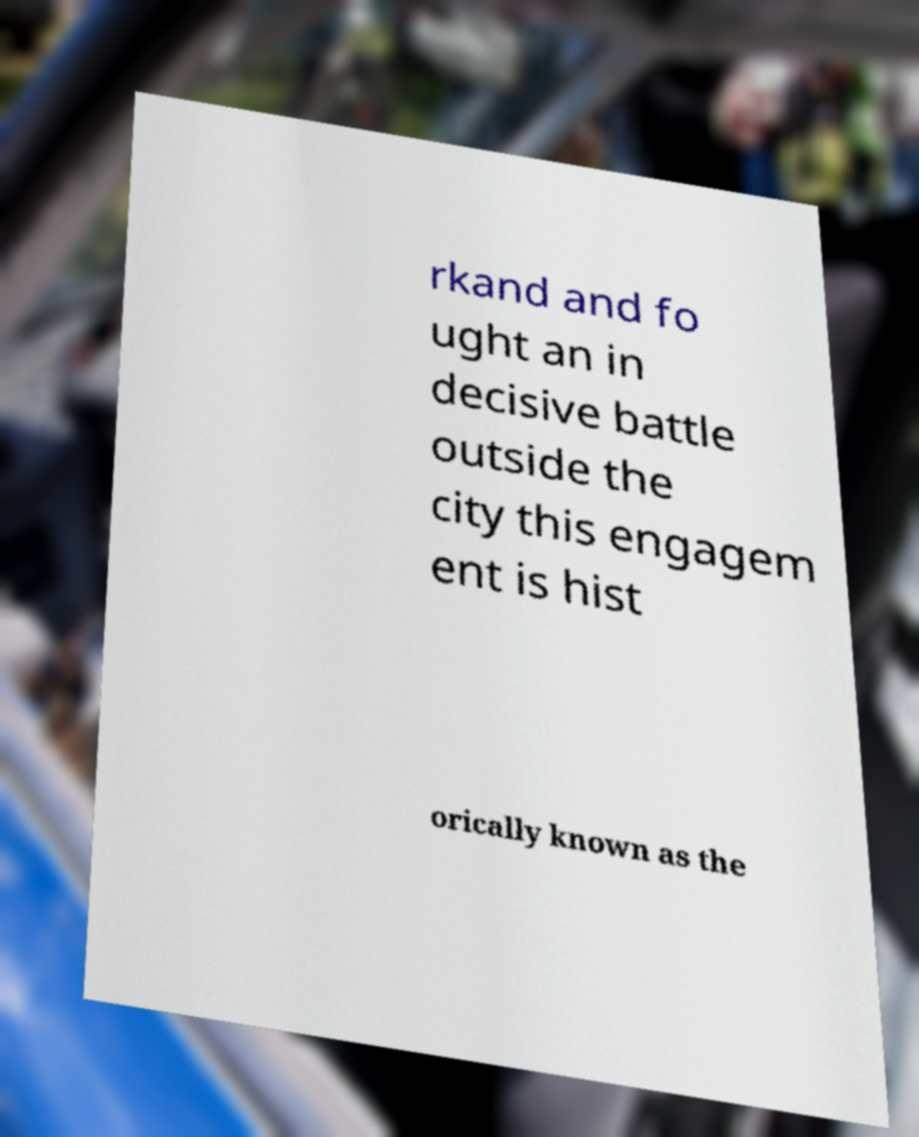What messages or text are displayed in this image? I need them in a readable, typed format. rkand and fo ught an in decisive battle outside the city this engagem ent is hist orically known as the 